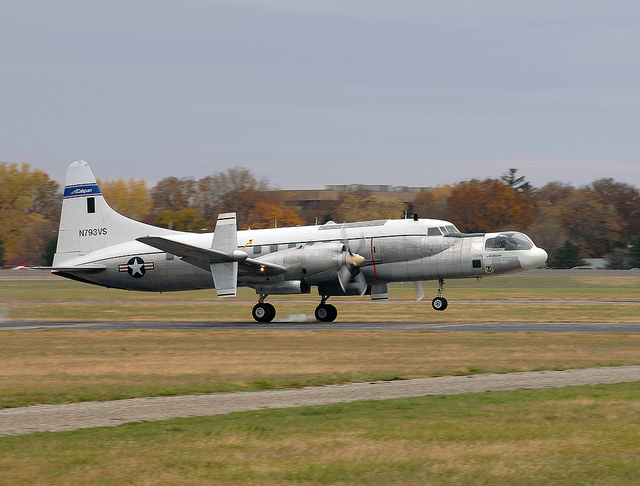Please transcribe the text in this image. N793BS 